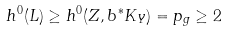<formula> <loc_0><loc_0><loc_500><loc_500>h ^ { 0 } ( L ) \geq h ^ { 0 } ( Z , b ^ { * } K _ { Y } ) = p _ { g } \geq 2</formula> 